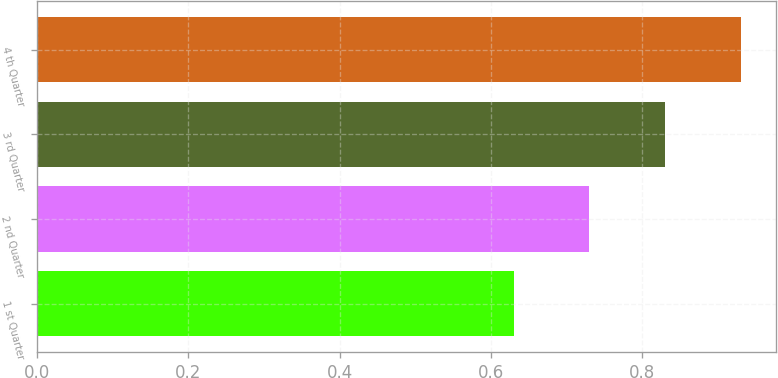Convert chart to OTSL. <chart><loc_0><loc_0><loc_500><loc_500><bar_chart><fcel>1 st Quarter<fcel>2 nd Quarter<fcel>3 rd Quarter<fcel>4 th Quarter<nl><fcel>0.63<fcel>0.73<fcel>0.83<fcel>0.93<nl></chart> 